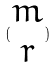Convert formula to latex. <formula><loc_0><loc_0><loc_500><loc_500>( \begin{matrix} m \\ r \end{matrix} )</formula> 